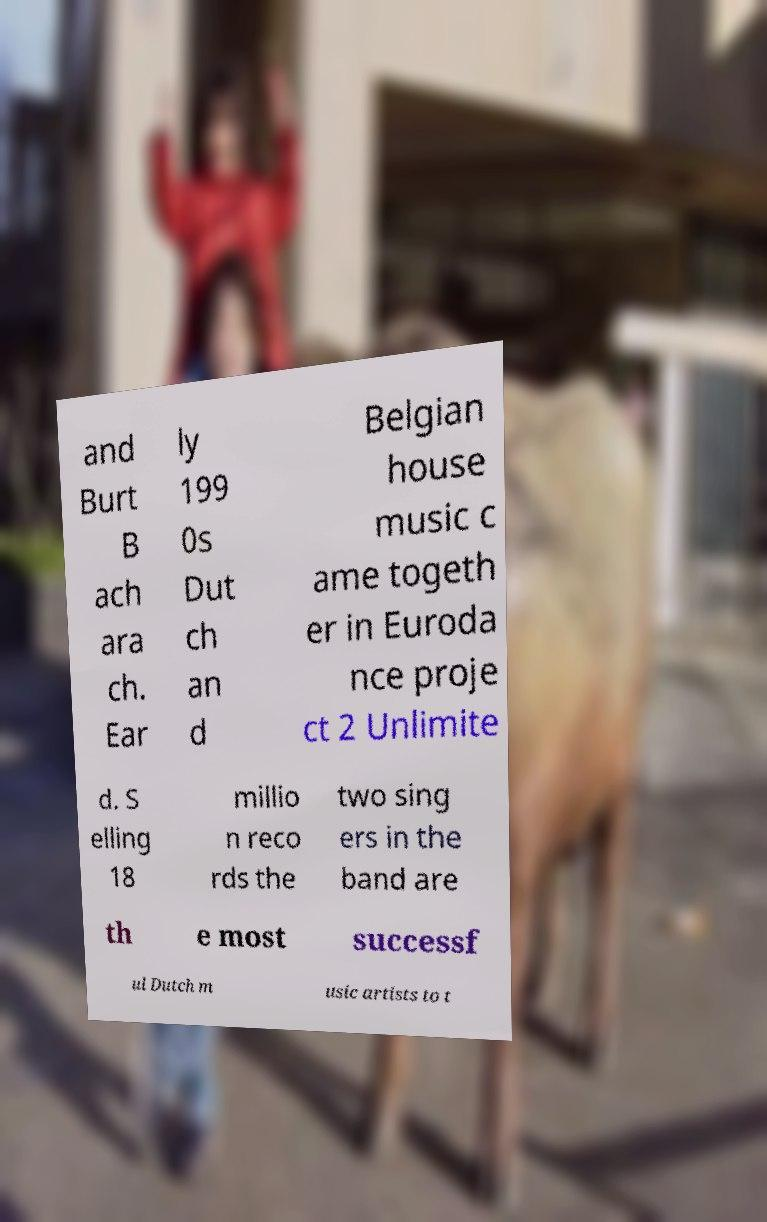Please read and relay the text visible in this image. What does it say? and Burt B ach ara ch. Ear ly 199 0s Dut ch an d Belgian house music c ame togeth er in Euroda nce proje ct 2 Unlimite d. S elling 18 millio n reco rds the two sing ers in the band are th e most successf ul Dutch m usic artists to t 